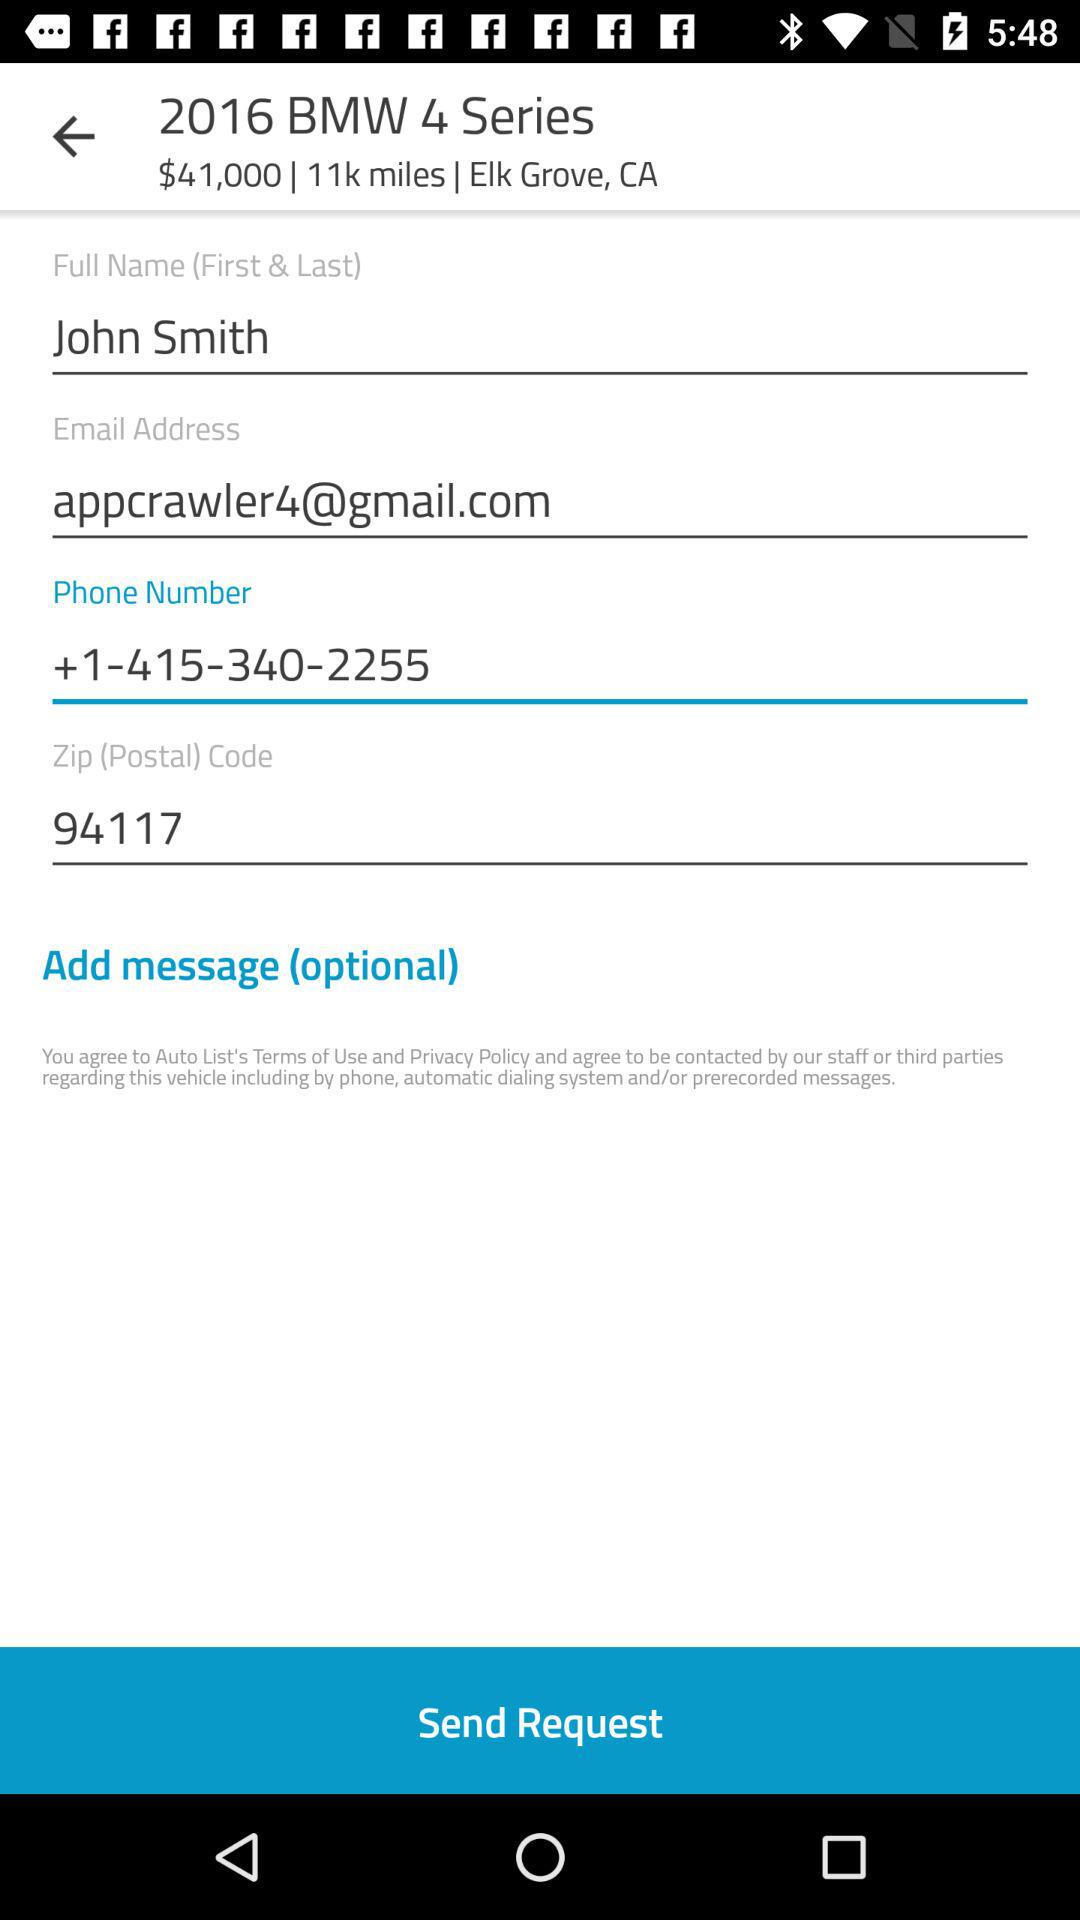What is the name of the user? The name of the user is John Smith. 